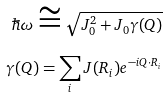Convert formula to latex. <formula><loc_0><loc_0><loc_500><loc_500>\hbar { \omega } \cong \sqrt { J _ { 0 } ^ { 2 } + J _ { 0 } \gamma ( Q ) } \\ \gamma ( Q ) = \sum _ { i } J ( R _ { i } ) e ^ { - i Q \cdot R _ { i } }</formula> 